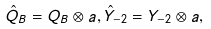<formula> <loc_0><loc_0><loc_500><loc_500>\hat { Q } _ { B } = Q _ { B } \otimes a , \hat { Y } _ { - 2 } = Y _ { - 2 } \otimes a ,</formula> 